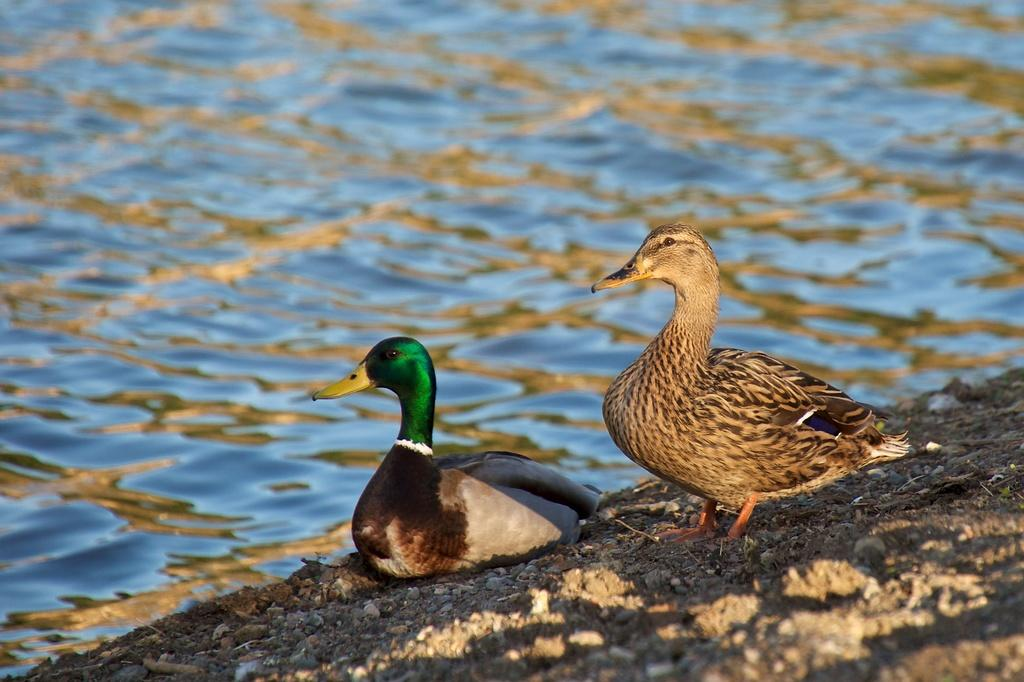How many birds are present in the image? There are two birds in the image. Where are the birds located in the image? The birds are on the ground. What can be seen in the background of the image? There is water visible in the background of the image. What type of plastic material can be seen in the image? There is no plastic material present in the image. Is there a harbor visible in the image? There is no harbor present in the image. Are the birds in the image being held in a jail? There is no indication in the image that the birds are being held in a jail. 